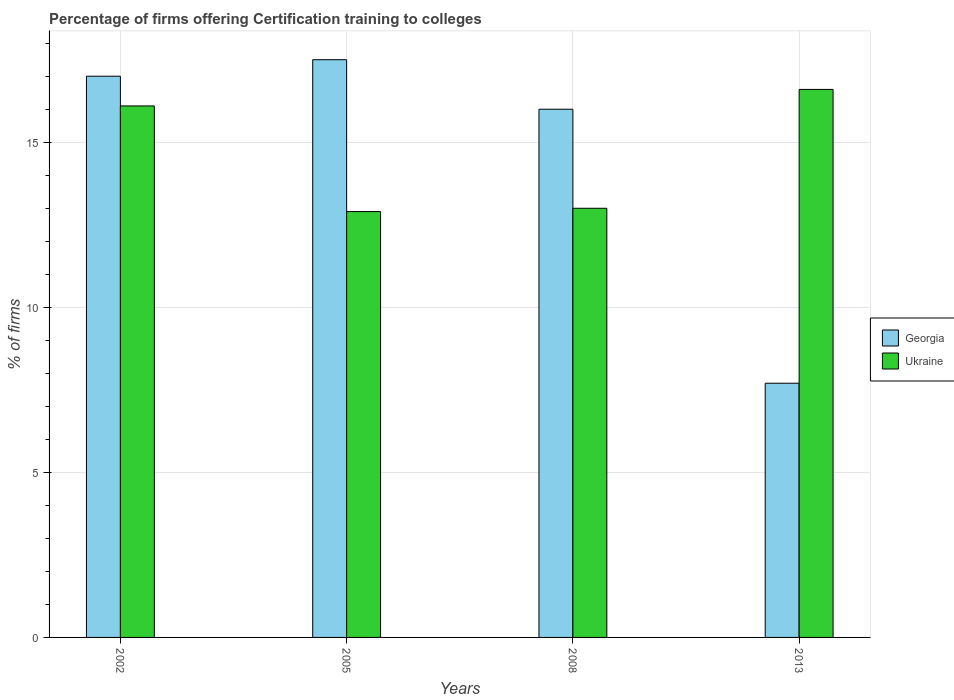How many different coloured bars are there?
Your answer should be compact. 2. How many groups of bars are there?
Keep it short and to the point. 4. Are the number of bars on each tick of the X-axis equal?
Offer a very short reply. Yes. What is the percentage of firms offering certification training to colleges in Georgia in 2008?
Provide a short and direct response. 16. In which year was the percentage of firms offering certification training to colleges in Georgia minimum?
Keep it short and to the point. 2013. What is the total percentage of firms offering certification training to colleges in Ukraine in the graph?
Your answer should be very brief. 58.6. What is the difference between the percentage of firms offering certification training to colleges in Ukraine in 2008 and the percentage of firms offering certification training to colleges in Georgia in 2013?
Make the answer very short. 5.3. What is the average percentage of firms offering certification training to colleges in Georgia per year?
Offer a very short reply. 14.55. In the year 2013, what is the difference between the percentage of firms offering certification training to colleges in Ukraine and percentage of firms offering certification training to colleges in Georgia?
Give a very brief answer. 8.9. What is the ratio of the percentage of firms offering certification training to colleges in Georgia in 2005 to that in 2013?
Your response must be concise. 2.27. What is the difference between the highest and the lowest percentage of firms offering certification training to colleges in Ukraine?
Your answer should be compact. 3.7. Is the sum of the percentage of firms offering certification training to colleges in Georgia in 2005 and 2013 greater than the maximum percentage of firms offering certification training to colleges in Ukraine across all years?
Provide a succinct answer. Yes. What does the 1st bar from the left in 2002 represents?
Your response must be concise. Georgia. What does the 2nd bar from the right in 2005 represents?
Your answer should be compact. Georgia. How many bars are there?
Keep it short and to the point. 8. What is the difference between two consecutive major ticks on the Y-axis?
Provide a succinct answer. 5. Does the graph contain any zero values?
Make the answer very short. No. Where does the legend appear in the graph?
Your answer should be compact. Center right. What is the title of the graph?
Your response must be concise. Percentage of firms offering Certification training to colleges. Does "Turkmenistan" appear as one of the legend labels in the graph?
Keep it short and to the point. No. What is the label or title of the Y-axis?
Your answer should be very brief. % of firms. What is the % of firms in Ukraine in 2008?
Your response must be concise. 13. What is the % of firms in Ukraine in 2013?
Make the answer very short. 16.6. Across all years, what is the maximum % of firms in Georgia?
Make the answer very short. 17.5. Across all years, what is the maximum % of firms of Ukraine?
Keep it short and to the point. 16.6. What is the total % of firms in Georgia in the graph?
Your response must be concise. 58.2. What is the total % of firms in Ukraine in the graph?
Keep it short and to the point. 58.6. What is the difference between the % of firms of Georgia in 2002 and that in 2008?
Ensure brevity in your answer.  1. What is the difference between the % of firms of Ukraine in 2002 and that in 2008?
Your response must be concise. 3.1. What is the difference between the % of firms of Georgia in 2005 and that in 2008?
Keep it short and to the point. 1.5. What is the difference between the % of firms in Georgia in 2005 and that in 2013?
Your answer should be compact. 9.8. What is the difference between the % of firms of Georgia in 2008 and that in 2013?
Offer a terse response. 8.3. What is the difference between the % of firms of Georgia in 2002 and the % of firms of Ukraine in 2008?
Your answer should be compact. 4. What is the difference between the % of firms in Georgia in 2002 and the % of firms in Ukraine in 2013?
Keep it short and to the point. 0.4. What is the difference between the % of firms of Georgia in 2005 and the % of firms of Ukraine in 2008?
Offer a very short reply. 4.5. What is the difference between the % of firms of Georgia in 2005 and the % of firms of Ukraine in 2013?
Provide a succinct answer. 0.9. What is the average % of firms of Georgia per year?
Give a very brief answer. 14.55. What is the average % of firms in Ukraine per year?
Offer a very short reply. 14.65. In the year 2013, what is the difference between the % of firms of Georgia and % of firms of Ukraine?
Your answer should be compact. -8.9. What is the ratio of the % of firms of Georgia in 2002 to that in 2005?
Your answer should be very brief. 0.97. What is the ratio of the % of firms in Ukraine in 2002 to that in 2005?
Make the answer very short. 1.25. What is the ratio of the % of firms in Georgia in 2002 to that in 2008?
Your answer should be very brief. 1.06. What is the ratio of the % of firms of Ukraine in 2002 to that in 2008?
Offer a very short reply. 1.24. What is the ratio of the % of firms in Georgia in 2002 to that in 2013?
Offer a terse response. 2.21. What is the ratio of the % of firms of Ukraine in 2002 to that in 2013?
Keep it short and to the point. 0.97. What is the ratio of the % of firms of Georgia in 2005 to that in 2008?
Ensure brevity in your answer.  1.09. What is the ratio of the % of firms of Ukraine in 2005 to that in 2008?
Provide a succinct answer. 0.99. What is the ratio of the % of firms of Georgia in 2005 to that in 2013?
Your response must be concise. 2.27. What is the ratio of the % of firms of Ukraine in 2005 to that in 2013?
Provide a succinct answer. 0.78. What is the ratio of the % of firms in Georgia in 2008 to that in 2013?
Provide a short and direct response. 2.08. What is the ratio of the % of firms in Ukraine in 2008 to that in 2013?
Your response must be concise. 0.78. What is the difference between the highest and the second highest % of firms of Georgia?
Ensure brevity in your answer.  0.5. What is the difference between the highest and the second highest % of firms of Ukraine?
Provide a succinct answer. 0.5. What is the difference between the highest and the lowest % of firms in Georgia?
Offer a terse response. 9.8. What is the difference between the highest and the lowest % of firms of Ukraine?
Ensure brevity in your answer.  3.7. 